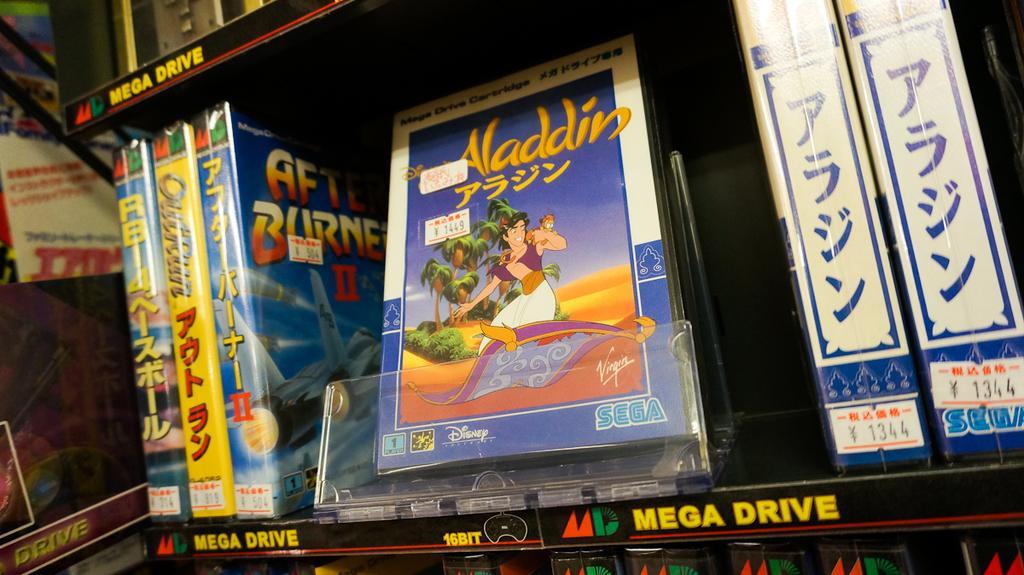In one or two sentences, can you explain what this image depicts? In this image we can see some books in a rack, on the books we can see some images and text. 